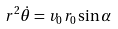Convert formula to latex. <formula><loc_0><loc_0><loc_500><loc_500>r ^ { 2 } { \dot { \theta } } = v _ { 0 } r _ { 0 } \sin \alpha</formula> 